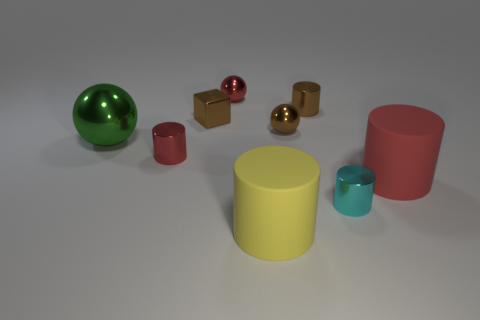The red matte thing that is the same size as the yellow thing is what shape?
Your answer should be very brief. Cylinder. There is a small ball that is the same color as the small cube; what material is it?
Provide a short and direct response. Metal. There is a green sphere; are there any blocks in front of it?
Ensure brevity in your answer.  No. Are there any red metal things of the same shape as the cyan metallic object?
Provide a succinct answer. Yes. Is the shape of the large thing left of the yellow rubber cylinder the same as the tiny red shiny object that is in front of the tiny brown cube?
Give a very brief answer. No. Are there any brown metallic blocks that have the same size as the brown shiny cylinder?
Give a very brief answer. Yes. Are there the same number of red metal things behind the red shiny ball and matte objects that are to the right of the small cyan cylinder?
Your answer should be compact. No. Are the tiny ball that is in front of the small brown cylinder and the red object that is right of the tiny brown shiny cylinder made of the same material?
Keep it short and to the point. No. What is the block made of?
Your response must be concise. Metal. What number of other objects are the same color as the block?
Give a very brief answer. 2. 